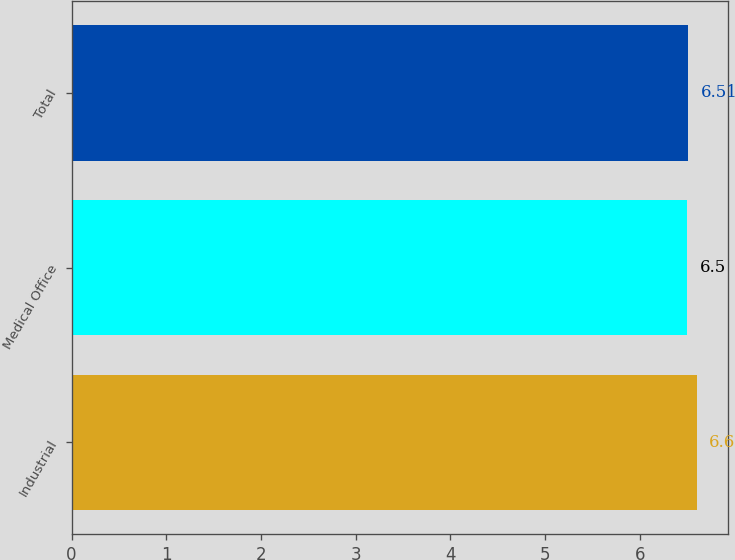Convert chart to OTSL. <chart><loc_0><loc_0><loc_500><loc_500><bar_chart><fcel>Industrial<fcel>Medical Office<fcel>Total<nl><fcel>6.6<fcel>6.5<fcel>6.51<nl></chart> 